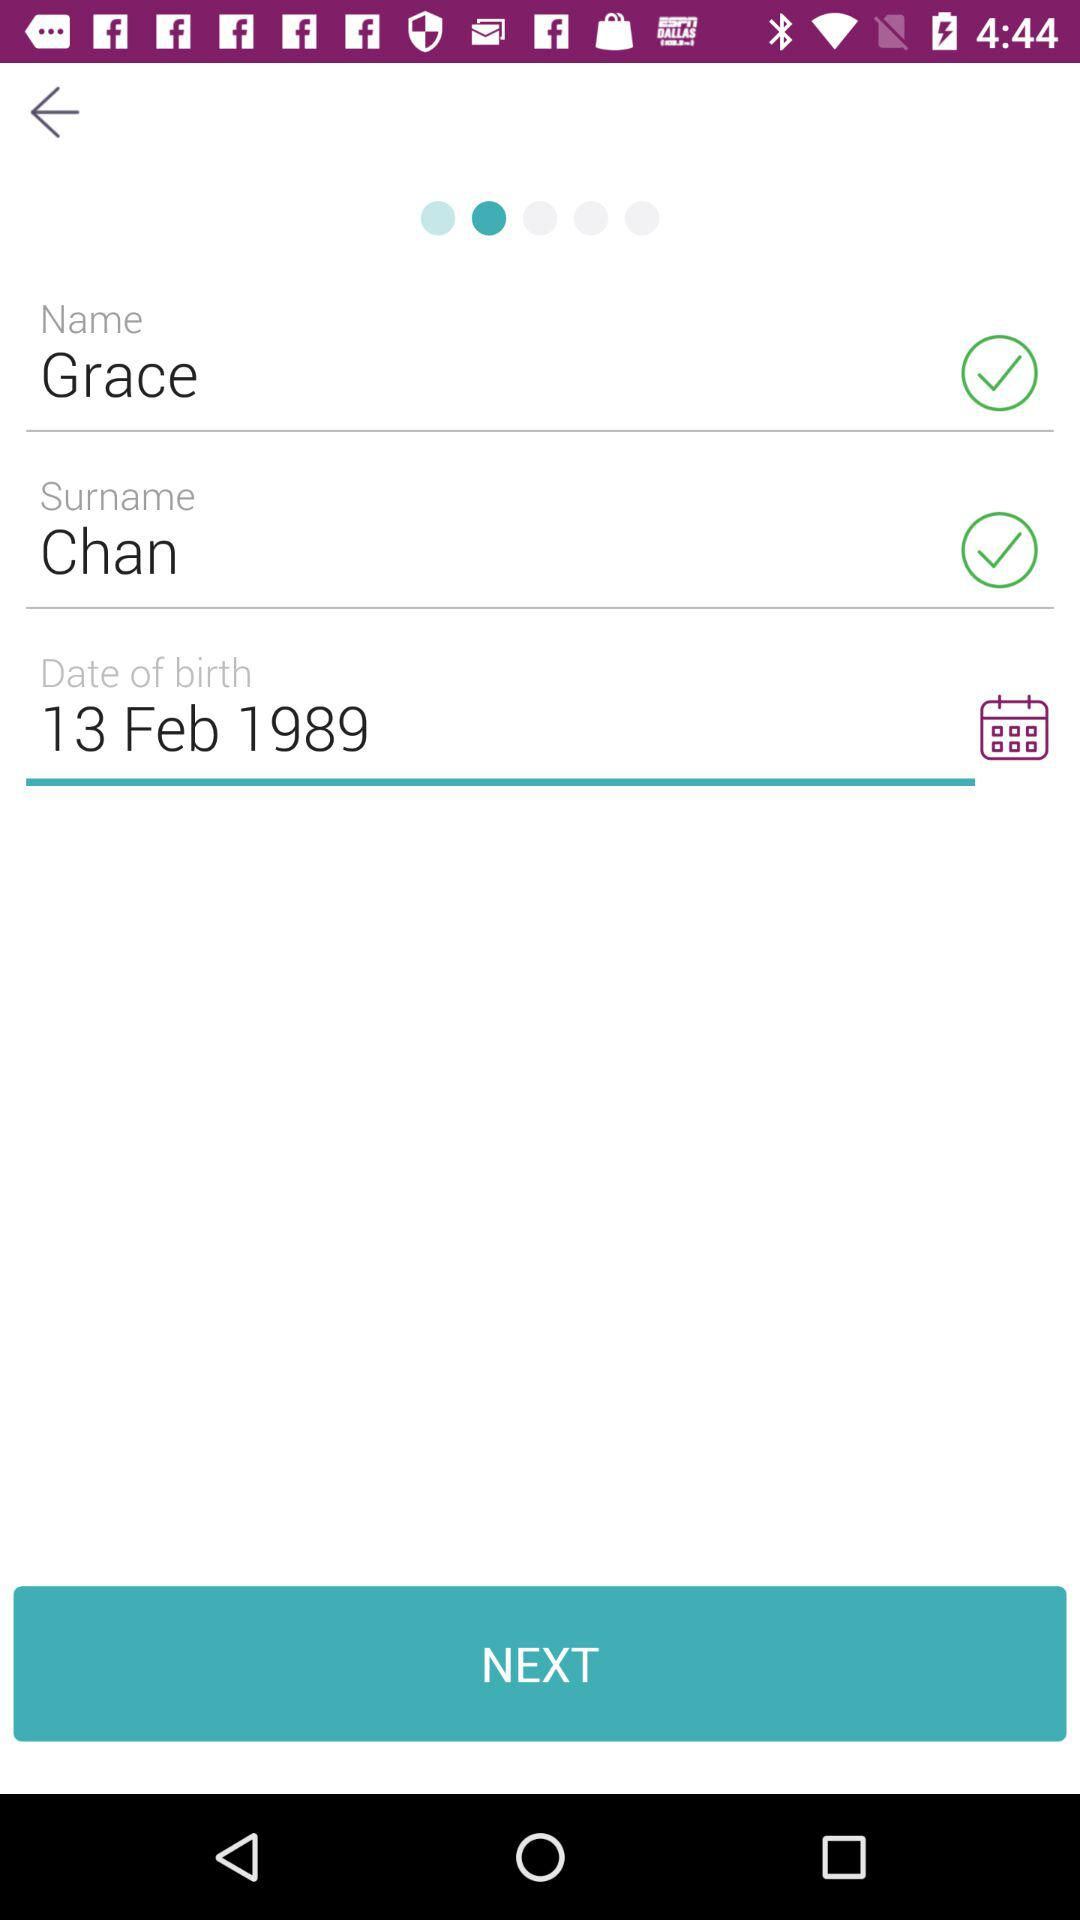What is the surname of the user? The surname of the user is Chan. 